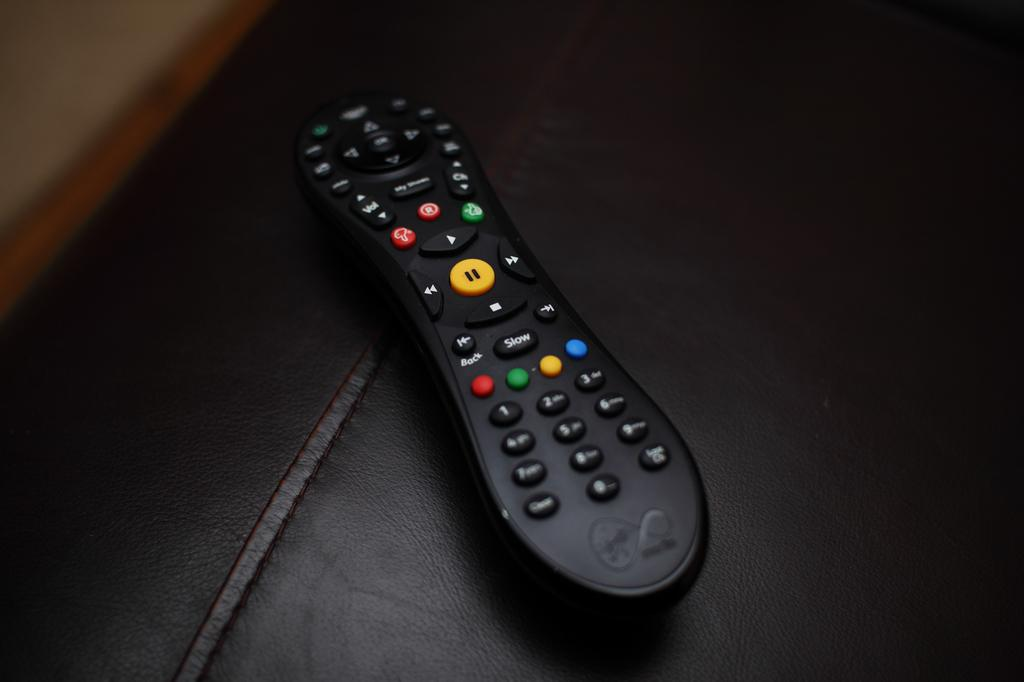<image>
Render a clear and concise summary of the photo. A black remote control with a slow and back bottoms. 